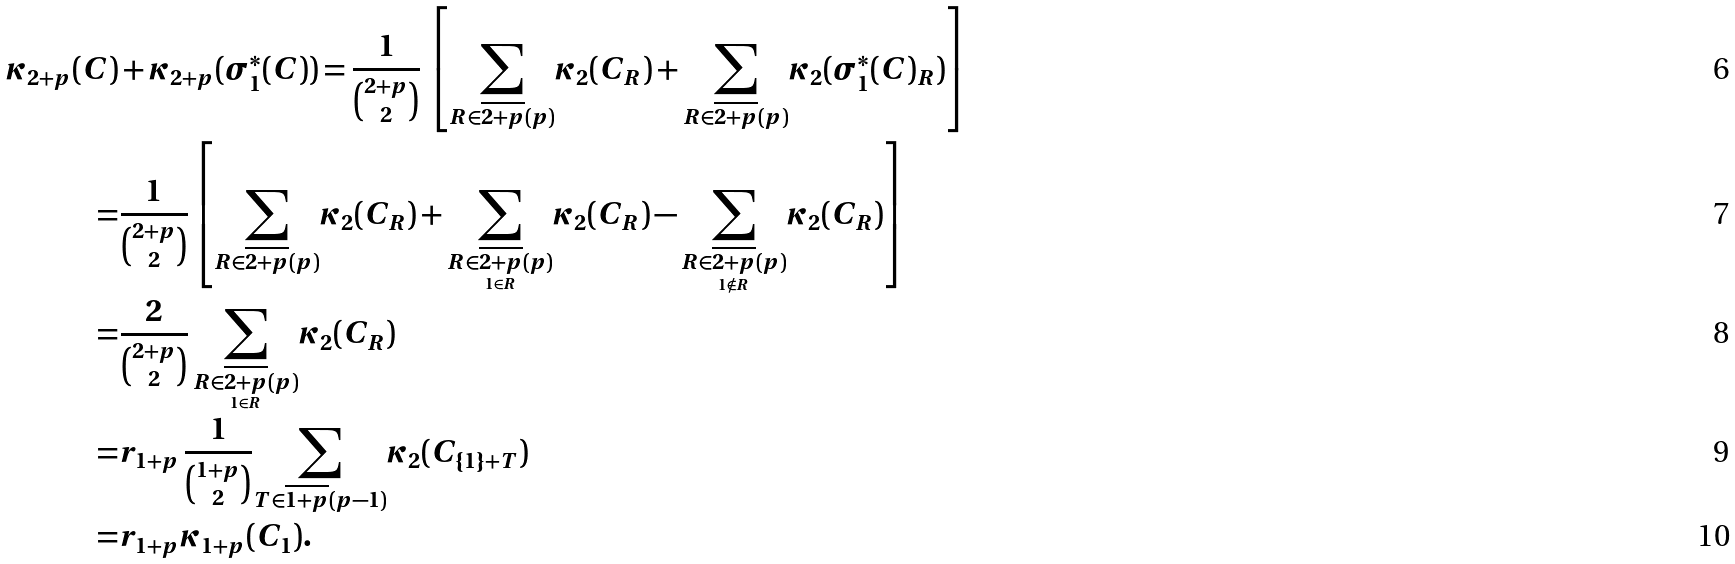Convert formula to latex. <formula><loc_0><loc_0><loc_500><loc_500>\kappa _ { 2 + p } ( C ) & + \kappa _ { 2 + p } ( \sigma _ { 1 } ^ { * } ( C ) ) = \frac { 1 } { \binom { 2 + p } { 2 } } \, \left [ \underset { R \in \overline { 2 + p } ( p ) } { \sum } \kappa _ { 2 } ( C _ { R } ) + \underset { R \in \overline { 2 + p } ( p ) } { \sum } \kappa _ { 2 } ( \sigma _ { 1 } ^ { * } ( C ) _ { R } ) \right ] \\ = & \frac { 1 } { \binom { 2 + p } { 2 } } \left [ \underset { R \in \overline { 2 + p } ( p ) } { \sum } \kappa _ { 2 } ( C _ { R } ) + \underset { \underset { 1 \in R } { R \in \overline { 2 + p } ( p ) } } { \sum } \kappa _ { 2 } ( C _ { R } ) - \underset { \underset { 1 \notin R } { R \in \overline { 2 + p } ( p ) } } { \sum } \kappa _ { 2 } ( C _ { R } ) \right ] \\ = & \frac { 2 } { \binom { 2 + p } { 2 } } \, \underset { \underset { 1 \in R } { R \in \overline { 2 + p } ( p ) } } { \sum } \kappa _ { 2 } ( C _ { R } ) \\ = & r _ { 1 + p } \, \frac { 1 } { \binom { 1 + p } { 2 } } \underset { T \in \overline { 1 + p } ( p - 1 ) } { \sum } \kappa _ { 2 } ( C _ { \{ 1 \} + T } ) \\ = & r _ { 1 + p } \kappa _ { 1 + p } ( C _ { 1 } ) .</formula> 